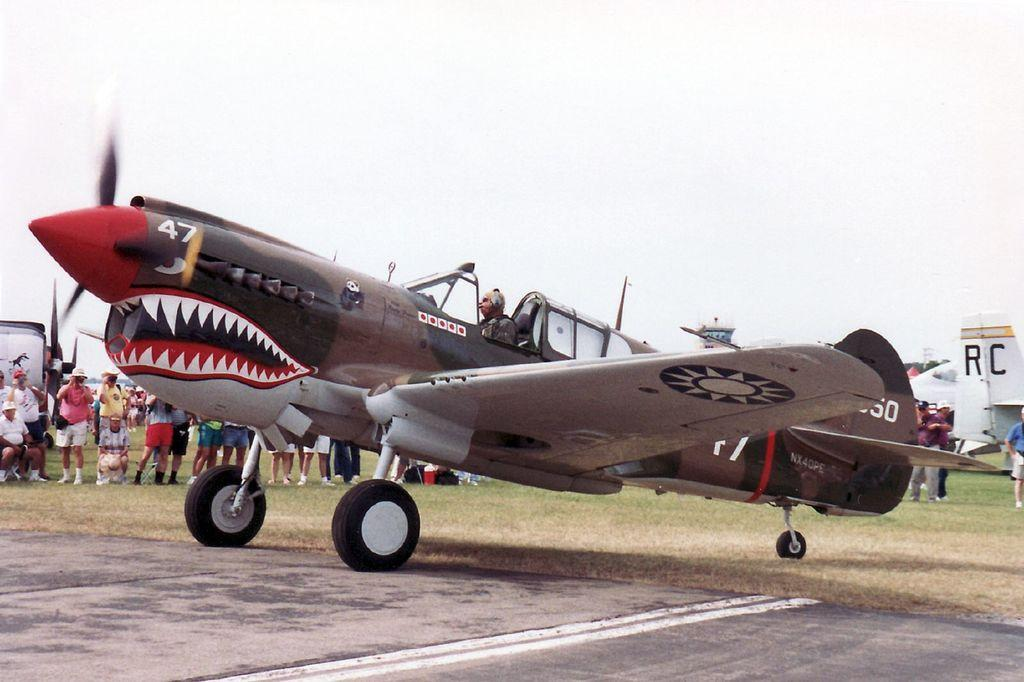<image>
Render a clear and concise summary of the photo. A World War II fighter plane with the number 47 on the nose is parked at an airshow. 